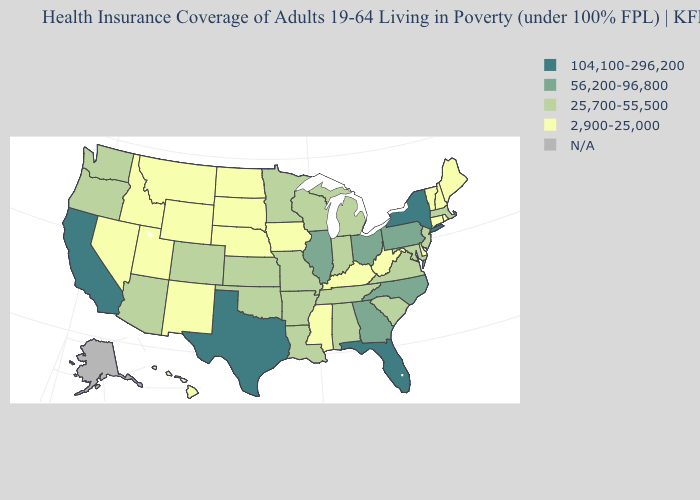What is the lowest value in the USA?
Short answer required. 2,900-25,000. What is the value of Indiana?
Write a very short answer. 25,700-55,500. Among the states that border Oregon , which have the lowest value?
Answer briefly. Idaho, Nevada. What is the value of North Dakota?
Be succinct. 2,900-25,000. Among the states that border Texas , which have the highest value?
Write a very short answer. Arkansas, Louisiana, Oklahoma. What is the lowest value in the South?
Answer briefly. 2,900-25,000. Does the map have missing data?
Quick response, please. Yes. Does Virginia have the highest value in the USA?
Be succinct. No. Name the states that have a value in the range 104,100-296,200?
Quick response, please. California, Florida, New York, Texas. How many symbols are there in the legend?
Write a very short answer. 5. What is the highest value in states that border Alabama?
Keep it brief. 104,100-296,200. Does the map have missing data?
Concise answer only. Yes. Which states have the lowest value in the USA?
Be succinct. Connecticut, Delaware, Hawaii, Idaho, Iowa, Kentucky, Maine, Mississippi, Montana, Nebraska, Nevada, New Hampshire, New Mexico, North Dakota, Rhode Island, South Dakota, Utah, Vermont, West Virginia, Wyoming. 